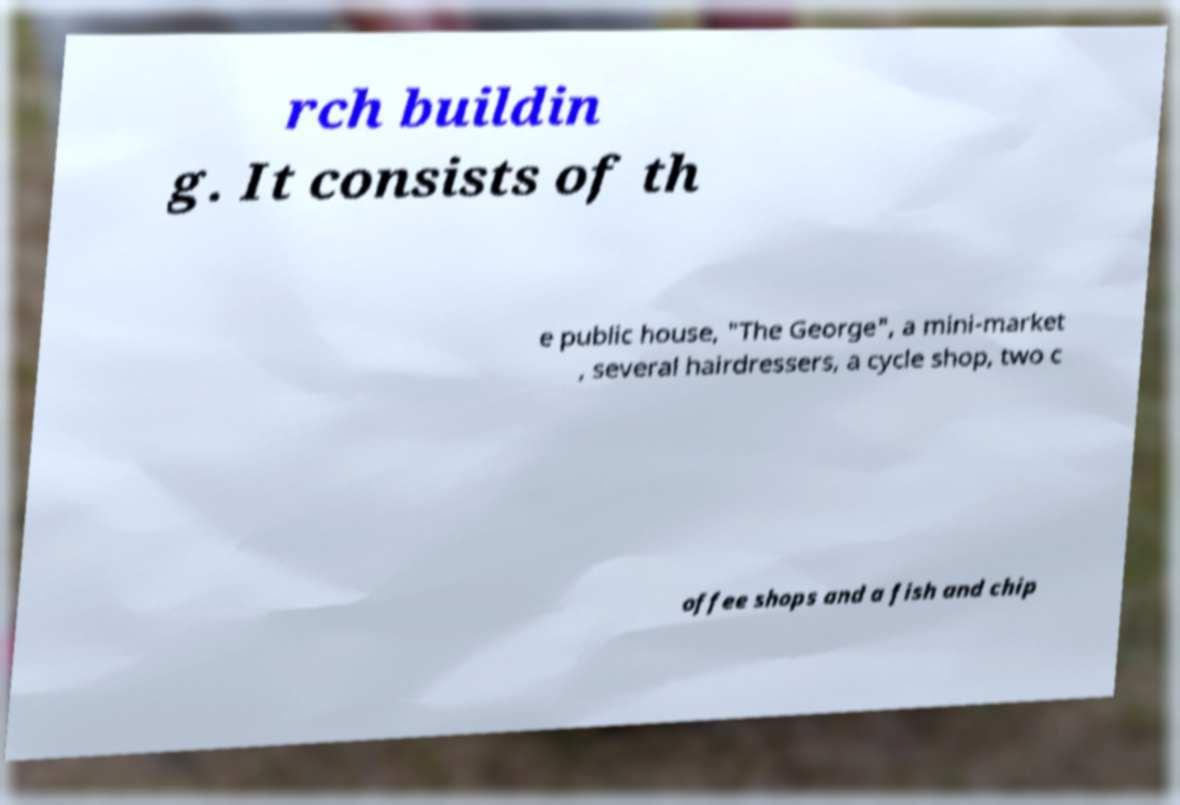Can you read and provide the text displayed in the image?This photo seems to have some interesting text. Can you extract and type it out for me? rch buildin g. It consists of th e public house, "The George", a mini-market , several hairdressers, a cycle shop, two c offee shops and a fish and chip 